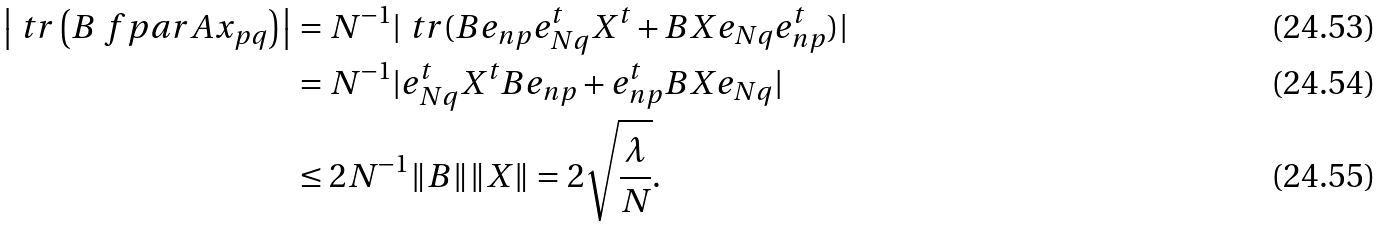<formula> <loc_0><loc_0><loc_500><loc_500>\left | \ t r \left ( B \ f p a r { A } { x _ { p q } } \right ) \right | & = N ^ { - 1 } | \ t r ( B e _ { n p } e _ { N q } ^ { t } X ^ { t } + B X e _ { N q } e _ { n p } ^ { t } ) | \\ & = N ^ { - 1 } | e _ { N q } ^ { t } X ^ { t } B e _ { n p } + e _ { n p } ^ { t } B X e _ { N q } | \\ & \leq 2 N ^ { - 1 } \| B \| \| X \| = 2 \sqrt { \frac { \lambda } { N } } .</formula> 